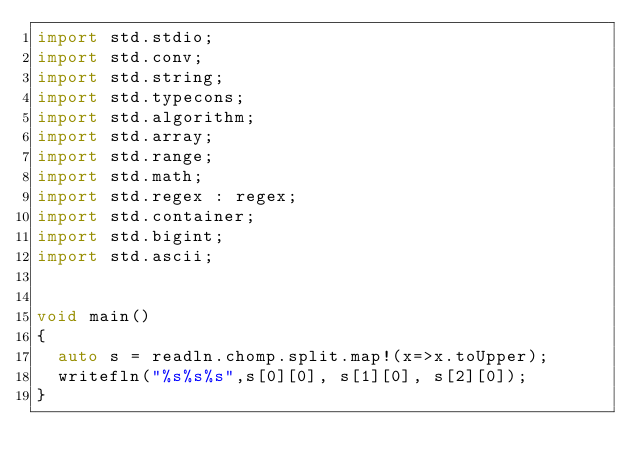<code> <loc_0><loc_0><loc_500><loc_500><_D_>import std.stdio;
import std.conv;
import std.string;
import std.typecons;
import std.algorithm;
import std.array;
import std.range;
import std.math;
import std.regex : regex;
import std.container;
import std.bigint;
import std.ascii;


void main()
{
  auto s = readln.chomp.split.map!(x=>x.toUpper);
  writefln("%s%s%s",s[0][0], s[1][0], s[2][0]);
}
</code> 